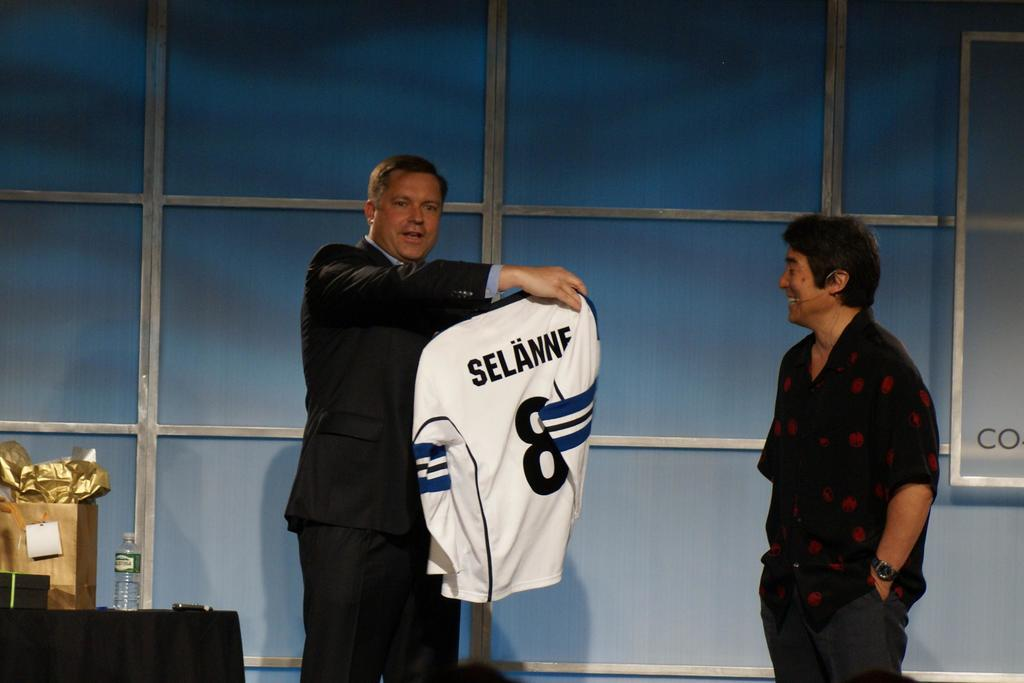<image>
Summarize the visual content of the image. Man holding a jersey that has Selanne in black letters on the back. 